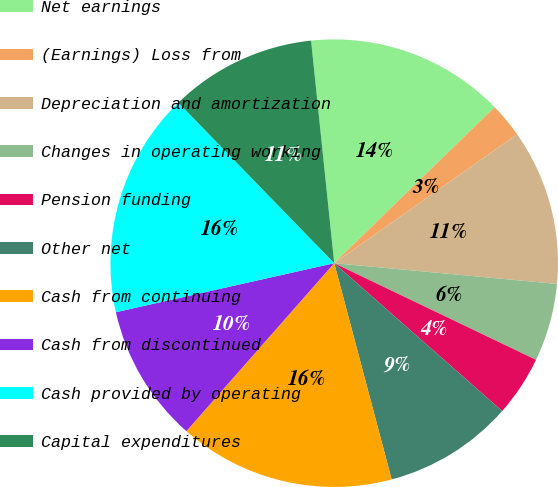Convert chart. <chart><loc_0><loc_0><loc_500><loc_500><pie_chart><fcel>Net earnings<fcel>(Earnings) Loss from<fcel>Depreciation and amortization<fcel>Changes in operating working<fcel>Pension funding<fcel>Other net<fcel>Cash from continuing<fcel>Cash from discontinued<fcel>Cash provided by operating<fcel>Capital expenditures<nl><fcel>14.37%<fcel>2.51%<fcel>11.25%<fcel>5.63%<fcel>4.38%<fcel>9.38%<fcel>15.62%<fcel>10.0%<fcel>16.25%<fcel>10.62%<nl></chart> 